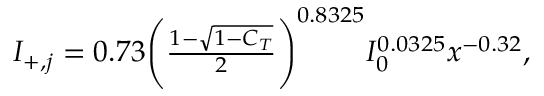<formula> <loc_0><loc_0><loc_500><loc_500>\begin{array} { r } { I _ { + , j } = 0 . 7 3 \left ( \frac { 1 - \sqrt { 1 - C _ { T } } } { 2 } \right ) ^ { 0 . 8 3 2 5 } I _ { 0 } ^ { 0 . 0 3 2 5 } x ^ { - 0 . 3 2 } , } \end{array}</formula> 